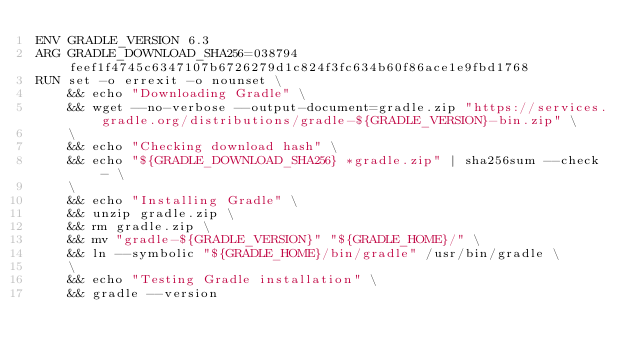<code> <loc_0><loc_0><loc_500><loc_500><_Dockerfile_>ENV GRADLE_VERSION 6.3
ARG GRADLE_DOWNLOAD_SHA256=038794feef1f4745c6347107b6726279d1c824f3fc634b60f86ace1e9fbd1768
RUN set -o errexit -o nounset \
    && echo "Downloading Gradle" \
    && wget --no-verbose --output-document=gradle.zip "https://services.gradle.org/distributions/gradle-${GRADLE_VERSION}-bin.zip" \
    \
    && echo "Checking download hash" \
    && echo "${GRADLE_DOWNLOAD_SHA256} *gradle.zip" | sha256sum --check - \
    \
    && echo "Installing Gradle" \
    && unzip gradle.zip \
    && rm gradle.zip \
    && mv "gradle-${GRADLE_VERSION}" "${GRADLE_HOME}/" \
    && ln --symbolic "${GRADLE_HOME}/bin/gradle" /usr/bin/gradle \
    \
    && echo "Testing Gradle installation" \
    && gradle --version
</code> 